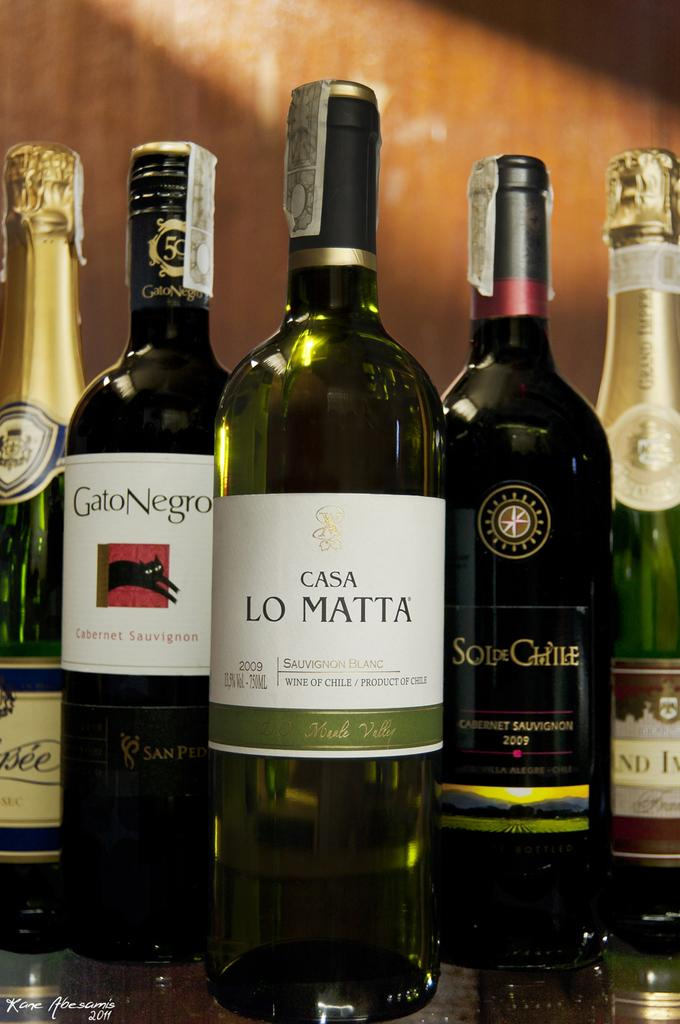How many wine bottles are on the table in the image? There are five wine bottles on the table in the image. What type of material is the wall in the background made of? The wall in the background is made of wood. What type of scarecrow is standing near the wine bottles in the image? There is no scarecrow present in the image. How many flies can be seen on the wine bottles in the image? There are no flies visible on the wine bottles in the image. 